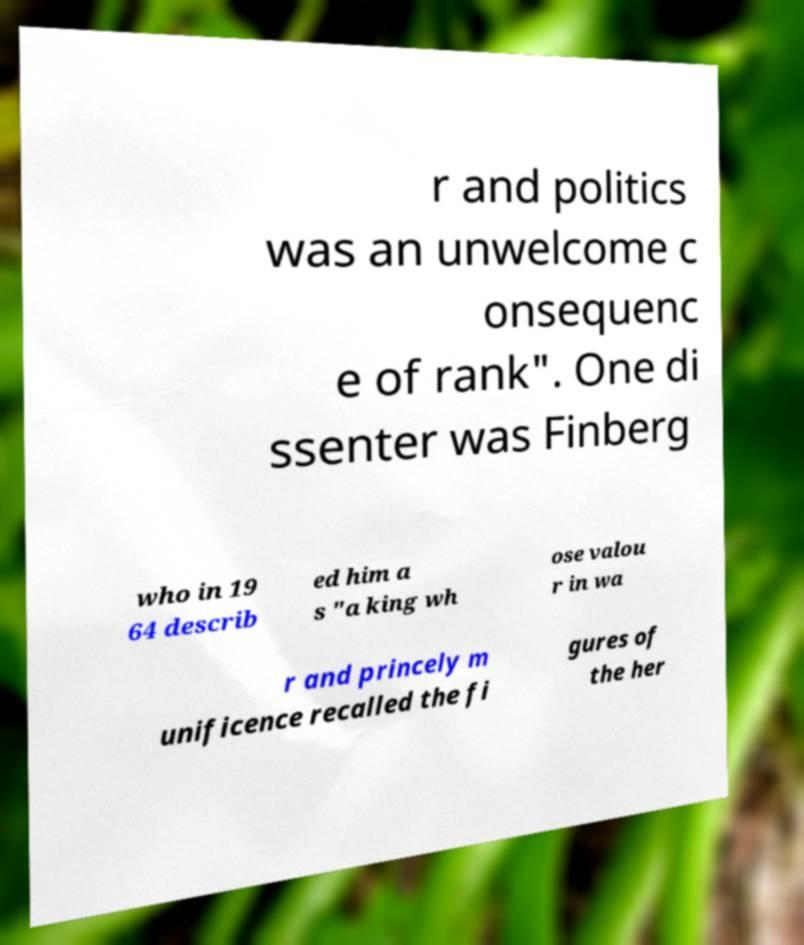What messages or text are displayed in this image? I need them in a readable, typed format. r and politics was an unwelcome c onsequenc e of rank". One di ssenter was Finberg who in 19 64 describ ed him a s "a king wh ose valou r in wa r and princely m unificence recalled the fi gures of the her 